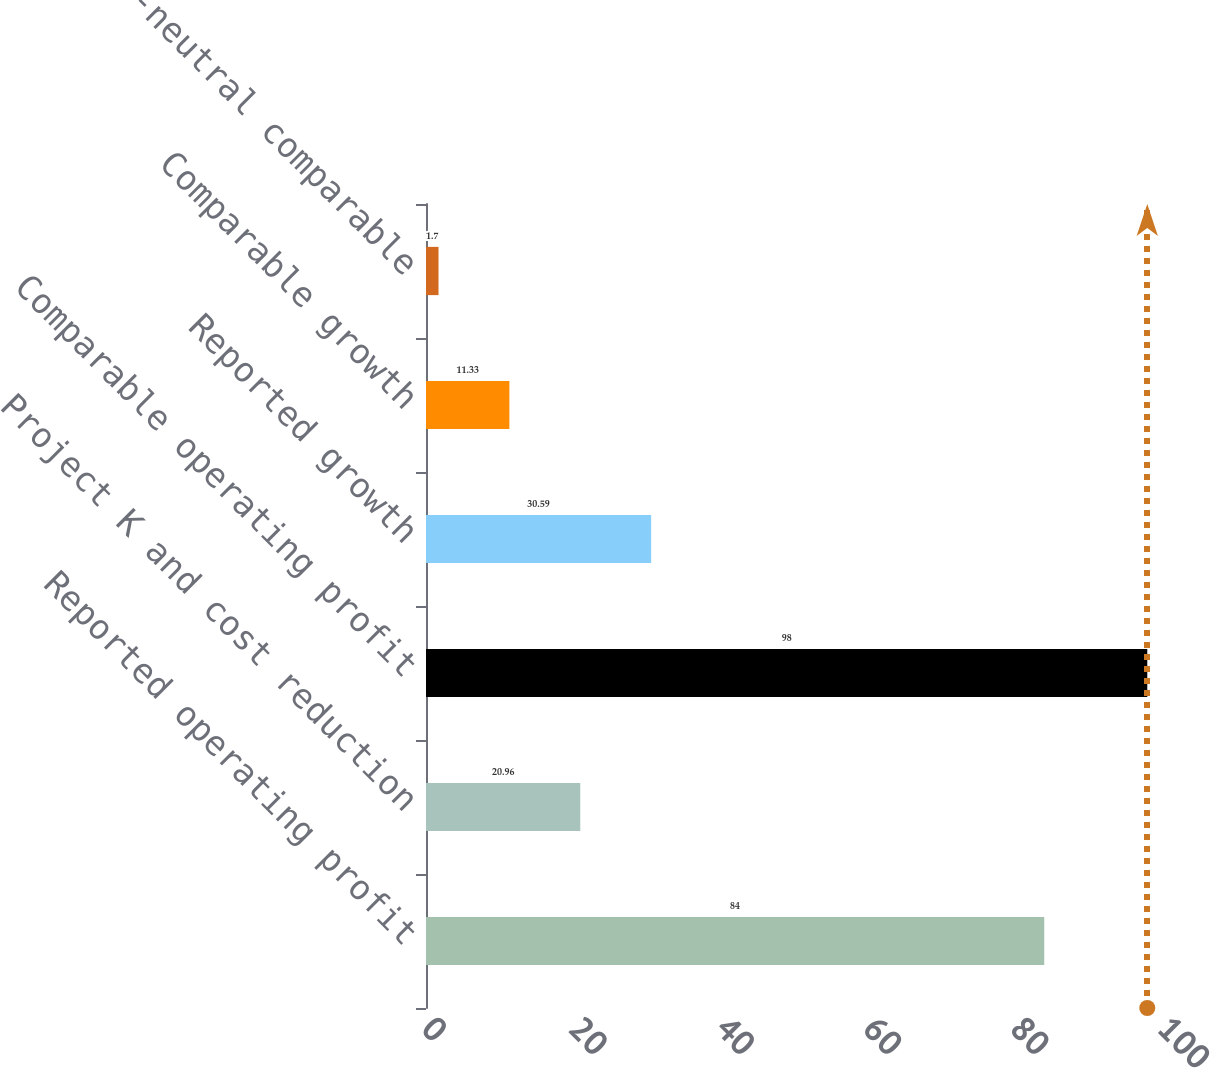Convert chart. <chart><loc_0><loc_0><loc_500><loc_500><bar_chart><fcel>Reported operating profit<fcel>Project K and cost reduction<fcel>Comparable operating profit<fcel>Reported growth<fcel>Comparable growth<fcel>Currency-neutral comparable<nl><fcel>84<fcel>20.96<fcel>98<fcel>30.59<fcel>11.33<fcel>1.7<nl></chart> 